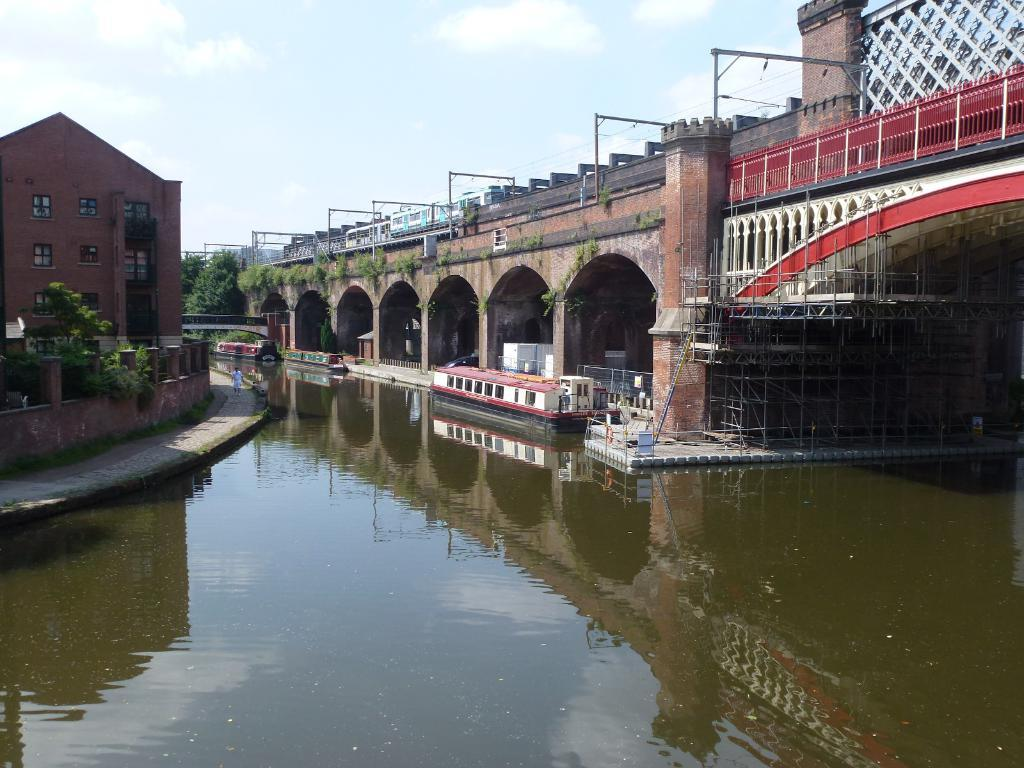What is the main structure in the center of the image? There is a bridge in the center of the image. What can be seen to the left side of the image? There is a building to the left side of the image. What is present in the center of the image besides the bridge? There is water in the center of the image. What type of lace can be seen hanging from the bridge in the image? There is no lace present on the bridge in the image. How many people are in the group standing on the bridge in the image? There is no group of people present on the bridge in the image. 